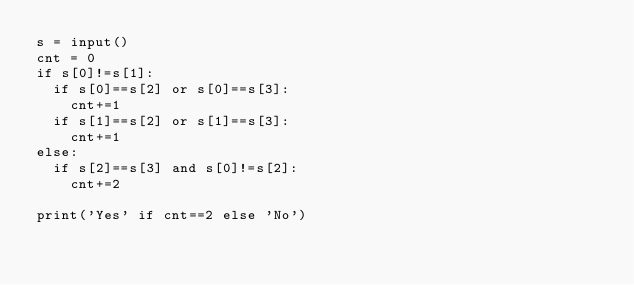Convert code to text. <code><loc_0><loc_0><loc_500><loc_500><_Python_>s = input()
cnt = 0
if s[0]!=s[1]:
  if s[0]==s[2] or s[0]==s[3]:
    cnt+=1
  if s[1]==s[2] or s[1]==s[3]:
    cnt+=1
else:
  if s[2]==s[3] and s[0]!=s[2]:
    cnt+=2
    
print('Yes' if cnt==2 else 'No')</code> 